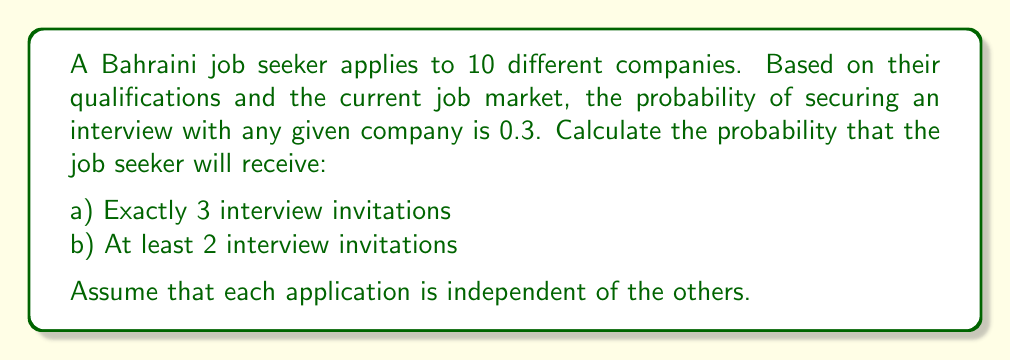Teach me how to tackle this problem. This problem can be solved using the binomial probability distribution.

Let X be the random variable representing the number of interview invitations received.

Given:
- n = 10 (number of companies applied to)
- p = 0.3 (probability of securing an interview with any given company)
- q = 1 - p = 0.7 (probability of not securing an interview)

a) For exactly 3 interview invitations:
We use the binomial probability formula:

$$P(X = k) = \binom{n}{k} p^k q^{n-k}$$

Where $\binom{n}{k}$ is the binomial coefficient.

$$P(X = 3) = \binom{10}{3} (0.3)^3 (0.7)^7$$

$$= 120 \times 0.027 \times 0.0824$$

$$= 0.2668$$

b) For at least 2 interview invitations:
We can calculate this as 1 minus the probability of receiving 0 or 1 invitation:

$$P(X \geq 2) = 1 - [P(X = 0) + P(X = 1)]$$

$$= 1 - [\binom{10}{0} (0.3)^0 (0.7)^{10} + \binom{10}{1} (0.3)^1 (0.7)^9]$$

$$= 1 - [0.0282 + 0.1211]$$

$$= 1 - 0.1493$$

$$= 0.8507$$
Answer: a) 0.2668
b) 0.8507 